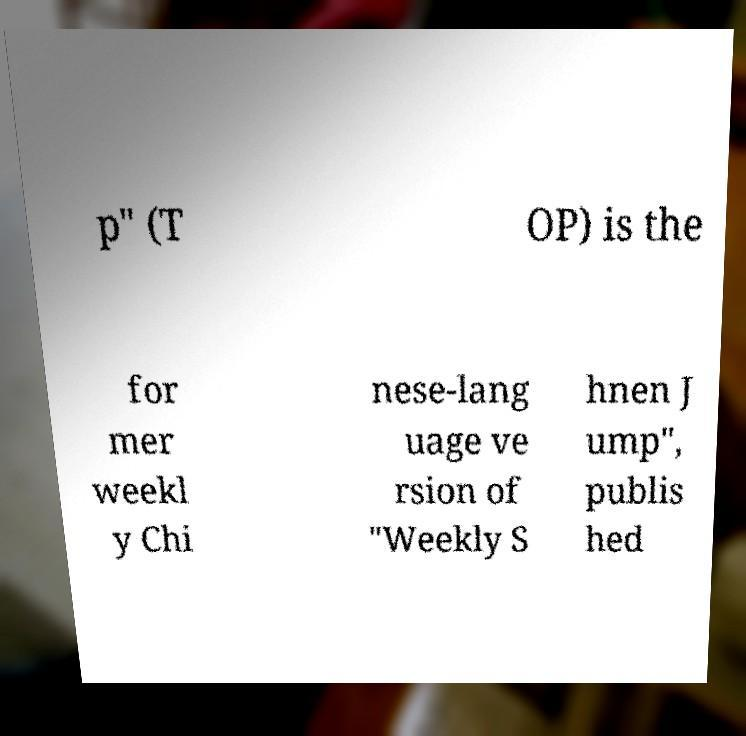Can you accurately transcribe the text from the provided image for me? p" (T OP) is the for mer weekl y Chi nese-lang uage ve rsion of "Weekly S hnen J ump", publis hed 